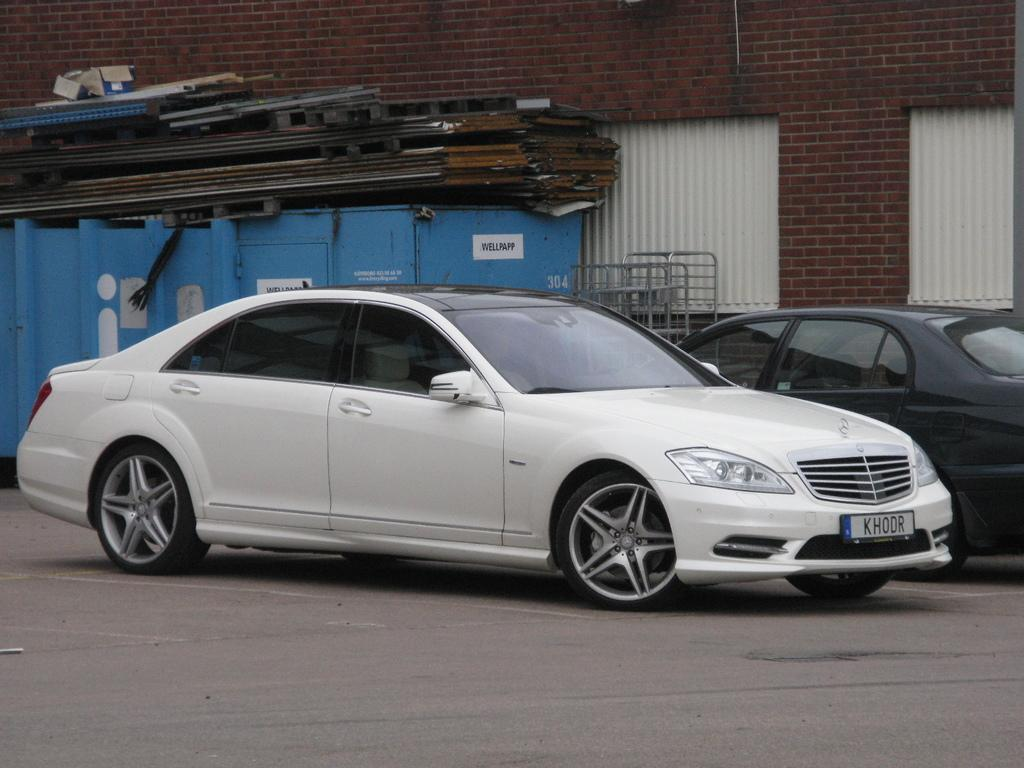How many cars are parked in the image? There are two cars parked in the image. Where are the cars parked in relation to the wall? The cars are parked beside a wall. What type of wall is visible behind the cars? There is a brick wall behind the cars. How many windows can be seen behind the cars? There are two windows visible behind the cars. What is the color of the object on the left side of the image? The object on the left side of the image is blue. How many women are sitting on the donkey in the image? There are no women or donkeys present in the image. 